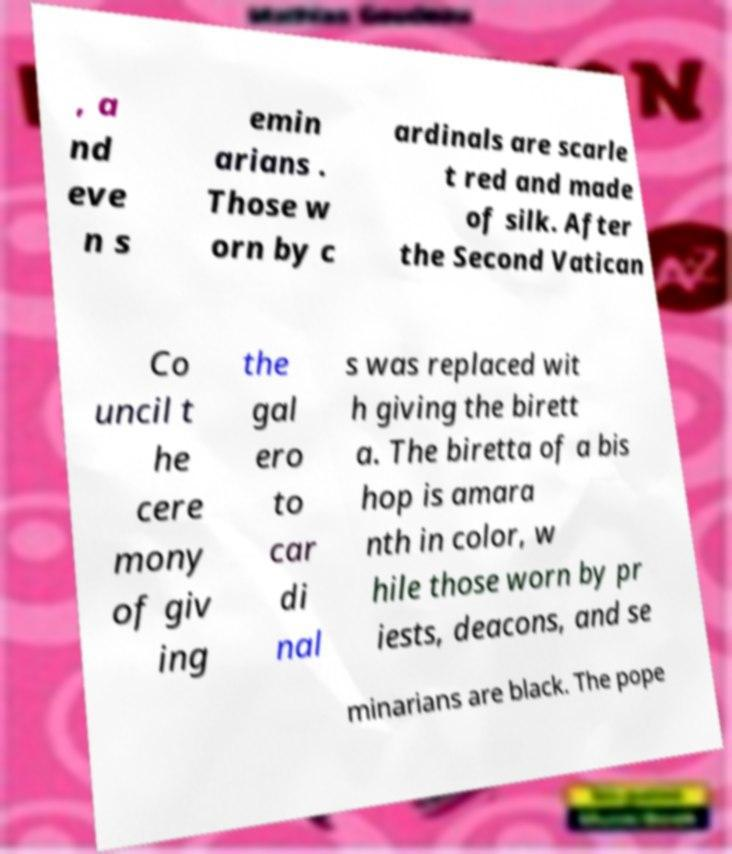For documentation purposes, I need the text within this image transcribed. Could you provide that? , a nd eve n s emin arians . Those w orn by c ardinals are scarle t red and made of silk. After the Second Vatican Co uncil t he cere mony of giv ing the gal ero to car di nal s was replaced wit h giving the birett a. The biretta of a bis hop is amara nth in color, w hile those worn by pr iests, deacons, and se minarians are black. The pope 